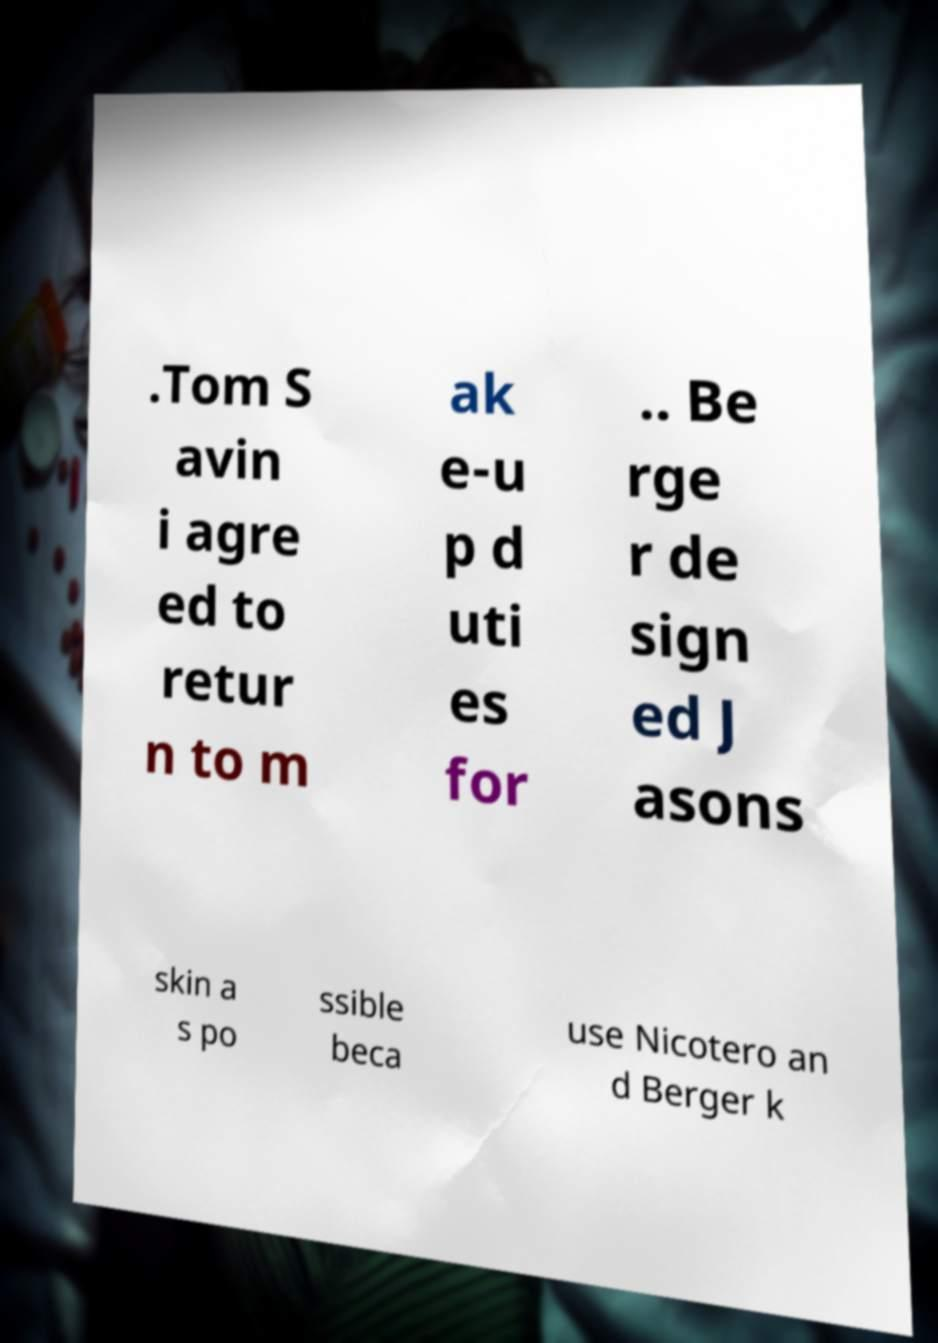Please read and relay the text visible in this image. What does it say? .Tom S avin i agre ed to retur n to m ak e-u p d uti es for .. Be rge r de sign ed J asons skin a s po ssible beca use Nicotero an d Berger k 